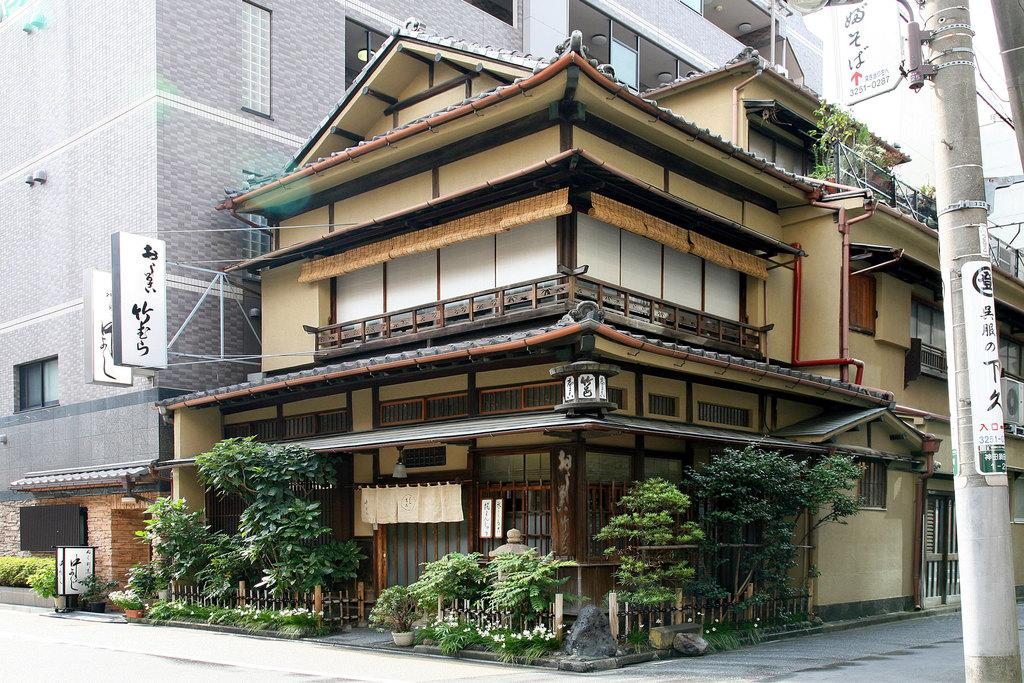Where was the image taken? The image was taken in a street. What can be seen in the background of the image? There are buildings in the background. What type of vegetation is present in front of the buildings? Plants are present in front of the buildings. What is located on the right side of the image? There is an electric pole on the right side of the image. How does the image show an increase in temperature during winter? The image does not show any information about temperature or season, so it cannot be used to demonstrate an increase in temperature during winter. 